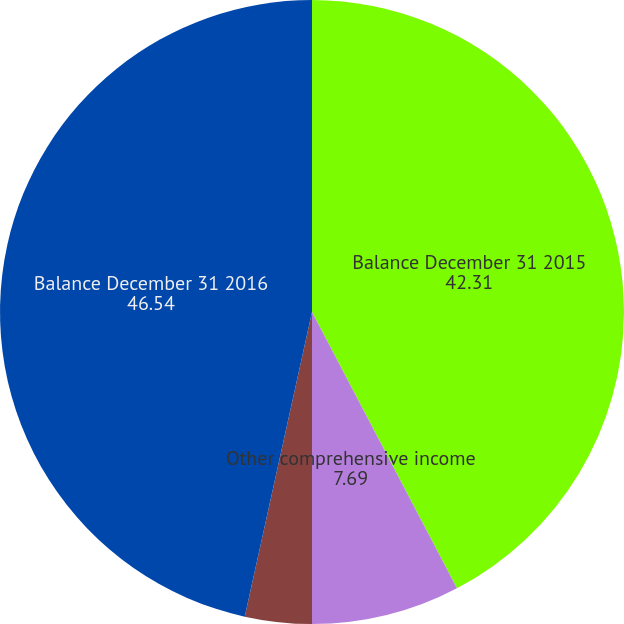Convert chart to OTSL. <chart><loc_0><loc_0><loc_500><loc_500><pie_chart><fcel>Balance December 31 2015<fcel>Other comprehensive income<fcel>Net current-period other<fcel>Balance December 31 2016<nl><fcel>42.31%<fcel>7.69%<fcel>3.46%<fcel>46.54%<nl></chart> 